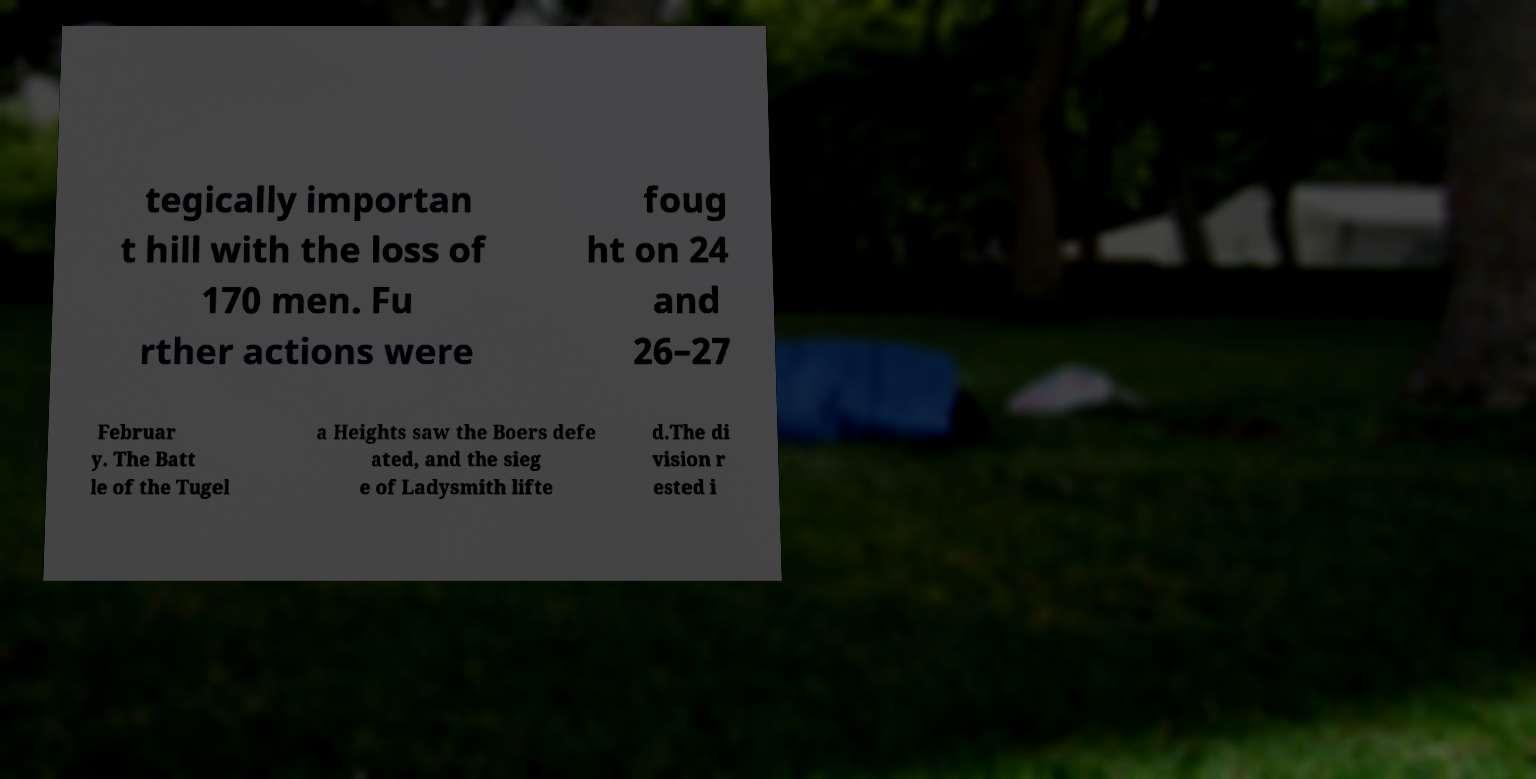Can you read and provide the text displayed in the image?This photo seems to have some interesting text. Can you extract and type it out for me? tegically importan t hill with the loss of 170 men. Fu rther actions were foug ht on 24 and 26–27 Februar y. The Batt le of the Tugel a Heights saw the Boers defe ated, and the sieg e of Ladysmith lifte d.The di vision r ested i 